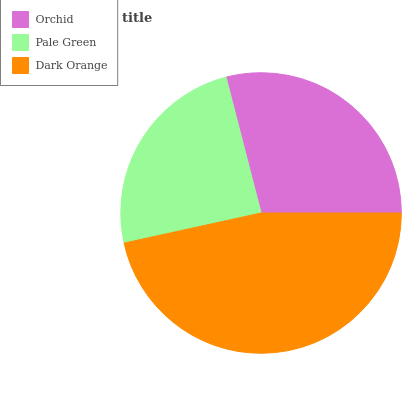Is Pale Green the minimum?
Answer yes or no. Yes. Is Dark Orange the maximum?
Answer yes or no. Yes. Is Dark Orange the minimum?
Answer yes or no. No. Is Pale Green the maximum?
Answer yes or no. No. Is Dark Orange greater than Pale Green?
Answer yes or no. Yes. Is Pale Green less than Dark Orange?
Answer yes or no. Yes. Is Pale Green greater than Dark Orange?
Answer yes or no. No. Is Dark Orange less than Pale Green?
Answer yes or no. No. Is Orchid the high median?
Answer yes or no. Yes. Is Orchid the low median?
Answer yes or no. Yes. Is Dark Orange the high median?
Answer yes or no. No. Is Dark Orange the low median?
Answer yes or no. No. 